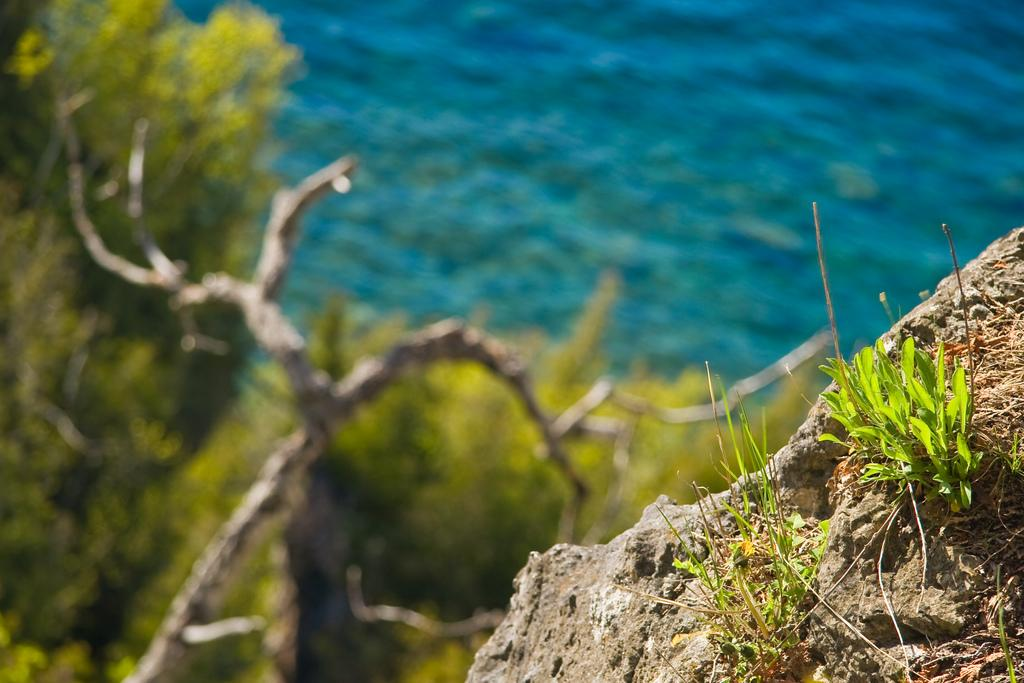What type of vegetation is present on the stone in the foreground of the image? There is grass on the stone in the foreground of the image. What can be seen in the background of the image? There are trees and water visible in the background of the image. How many cars are parked on the grass in the image? There are no cars present in the image. What type of motion can be observed in the image? There is no motion observable in the image; it appears to be a still scene. 